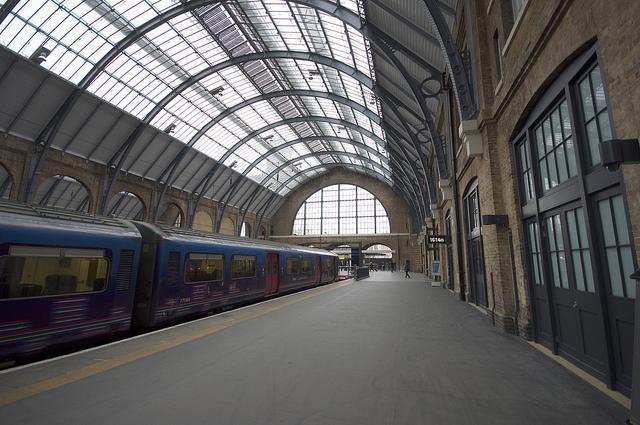How many train tracks are there?
Give a very brief answer. 1. How many measuring spoons are visible?
Give a very brief answer. 0. 